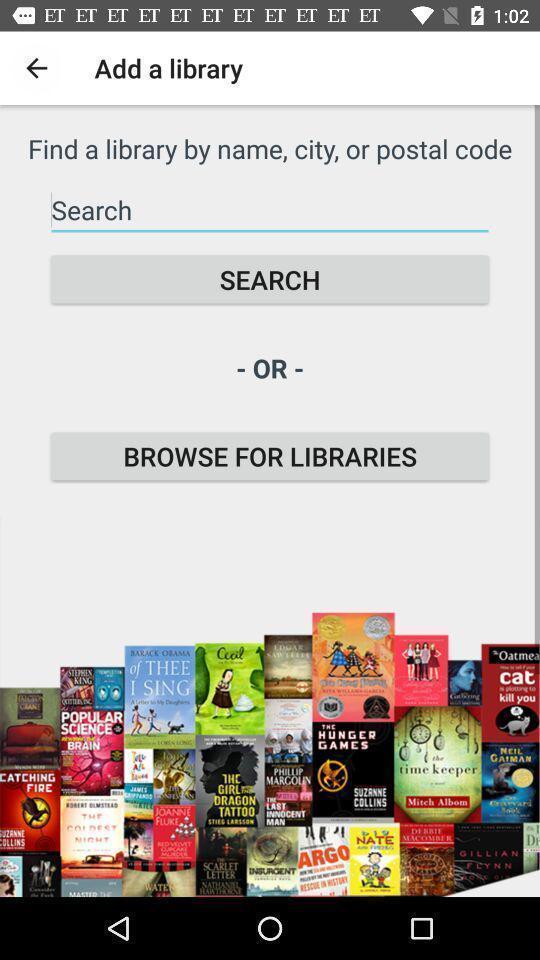Describe the visual elements of this screenshot. Screen shows to add a library. 